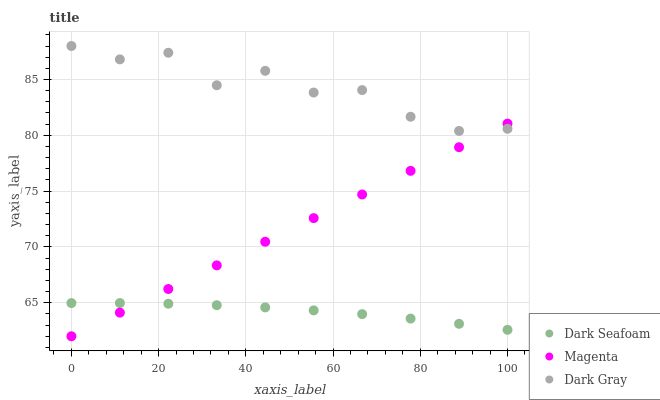Does Dark Seafoam have the minimum area under the curve?
Answer yes or no. Yes. Does Dark Gray have the maximum area under the curve?
Answer yes or no. Yes. Does Magenta have the minimum area under the curve?
Answer yes or no. No. Does Magenta have the maximum area under the curve?
Answer yes or no. No. Is Magenta the smoothest?
Answer yes or no. Yes. Is Dark Gray the roughest?
Answer yes or no. Yes. Is Dark Seafoam the smoothest?
Answer yes or no. No. Is Dark Seafoam the roughest?
Answer yes or no. No. Does Magenta have the lowest value?
Answer yes or no. Yes. Does Dark Seafoam have the lowest value?
Answer yes or no. No. Does Dark Gray have the highest value?
Answer yes or no. Yes. Does Magenta have the highest value?
Answer yes or no. No. Is Dark Seafoam less than Dark Gray?
Answer yes or no. Yes. Is Dark Gray greater than Dark Seafoam?
Answer yes or no. Yes. Does Dark Gray intersect Magenta?
Answer yes or no. Yes. Is Dark Gray less than Magenta?
Answer yes or no. No. Is Dark Gray greater than Magenta?
Answer yes or no. No. Does Dark Seafoam intersect Dark Gray?
Answer yes or no. No. 